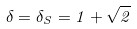Convert formula to latex. <formula><loc_0><loc_0><loc_500><loc_500>\delta = \delta _ { S } = 1 + \sqrt { 2 }</formula> 